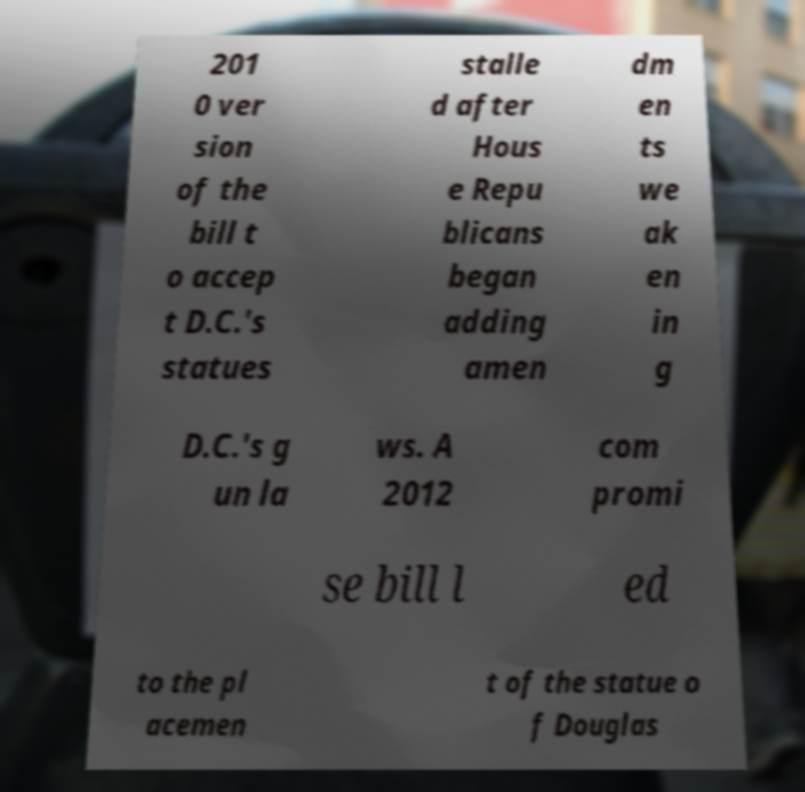Could you extract and type out the text from this image? 201 0 ver sion of the bill t o accep t D.C.'s statues stalle d after Hous e Repu blicans began adding amen dm en ts we ak en in g D.C.'s g un la ws. A 2012 com promi se bill l ed to the pl acemen t of the statue o f Douglas 